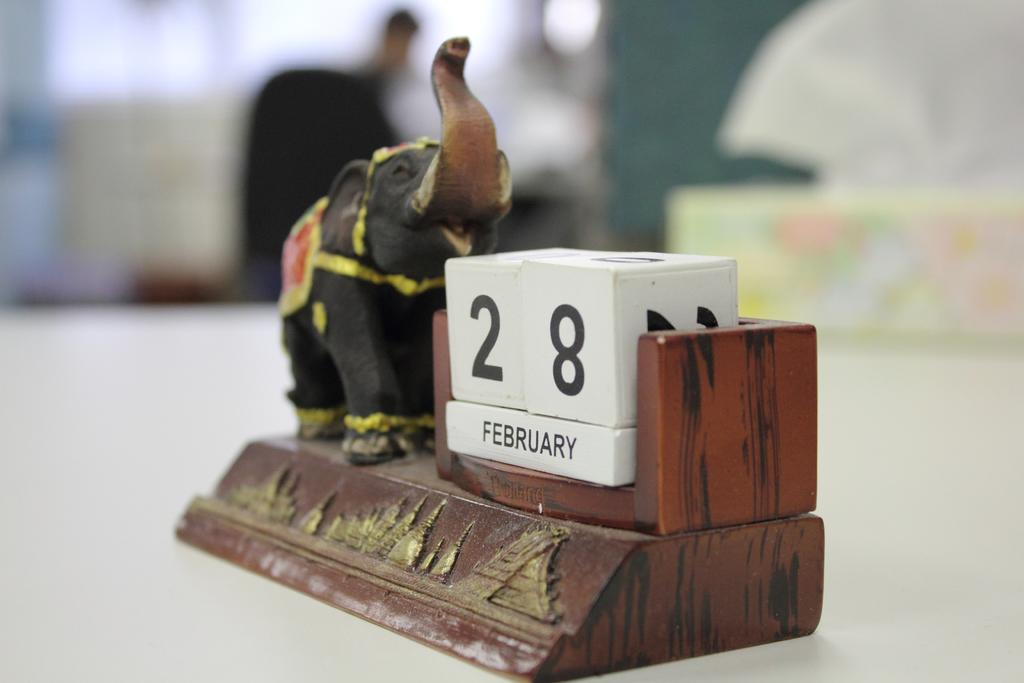<image>
Relay a brief, clear account of the picture shown. A wooden calendar brown sculpture with an elephant showing the date February 28. 